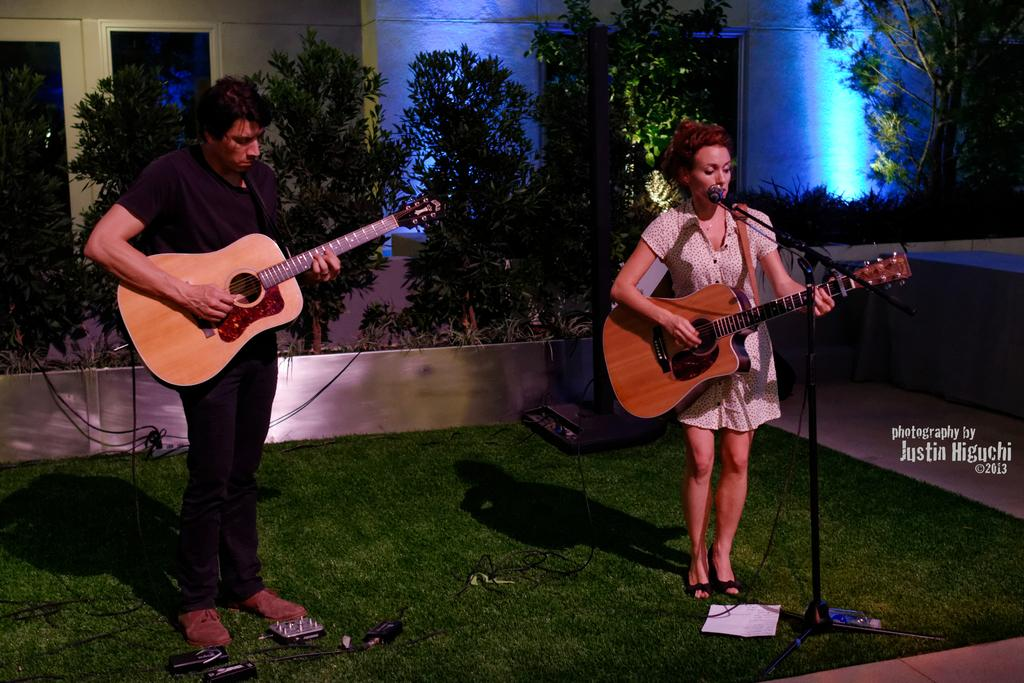How many people are in the image? There are two people in the image, a man and a woman. What are the man and woman holding in the image? The man and woman are holding a guitar. What is the woman doing in the image? The woman is singing in the image. How is the woman singing in the image? The woman is using a microphone to sing. Where is the microphone positioned in relation to the woman? The microphone is in front of the woman. What can be seen in the background of the image? There are trees present near the people in the image. What type of coil is being used by the band in the image? There is no band present in the image, and therefore no coil being used. What kind of pipe can be seen connecting the guitar to the microphone in the image? There is no pipe connecting the guitar to the microphone in the image. 